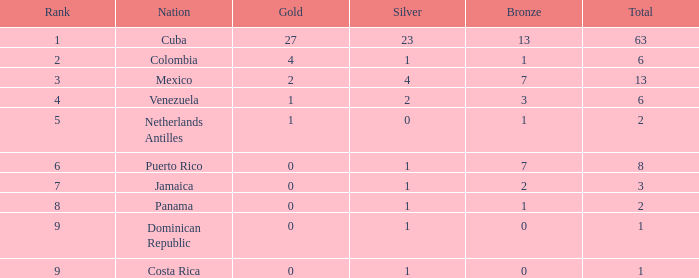Could you parse the entire table? {'header': ['Rank', 'Nation', 'Gold', 'Silver', 'Bronze', 'Total'], 'rows': [['1', 'Cuba', '27', '23', '13', '63'], ['2', 'Colombia', '4', '1', '1', '6'], ['3', 'Mexico', '2', '4', '7', '13'], ['4', 'Venezuela', '1', '2', '3', '6'], ['5', 'Netherlands Antilles', '1', '0', '1', '2'], ['6', 'Puerto Rico', '0', '1', '7', '8'], ['7', 'Jamaica', '0', '1', '2', '3'], ['8', 'Panama', '0', '1', '1', '2'], ['9', 'Dominican Republic', '0', '1', '0', '1'], ['9', 'Costa Rica', '0', '1', '0', '1']]} Which country has the minimal gold median with a ranking exceeding 9? None. 